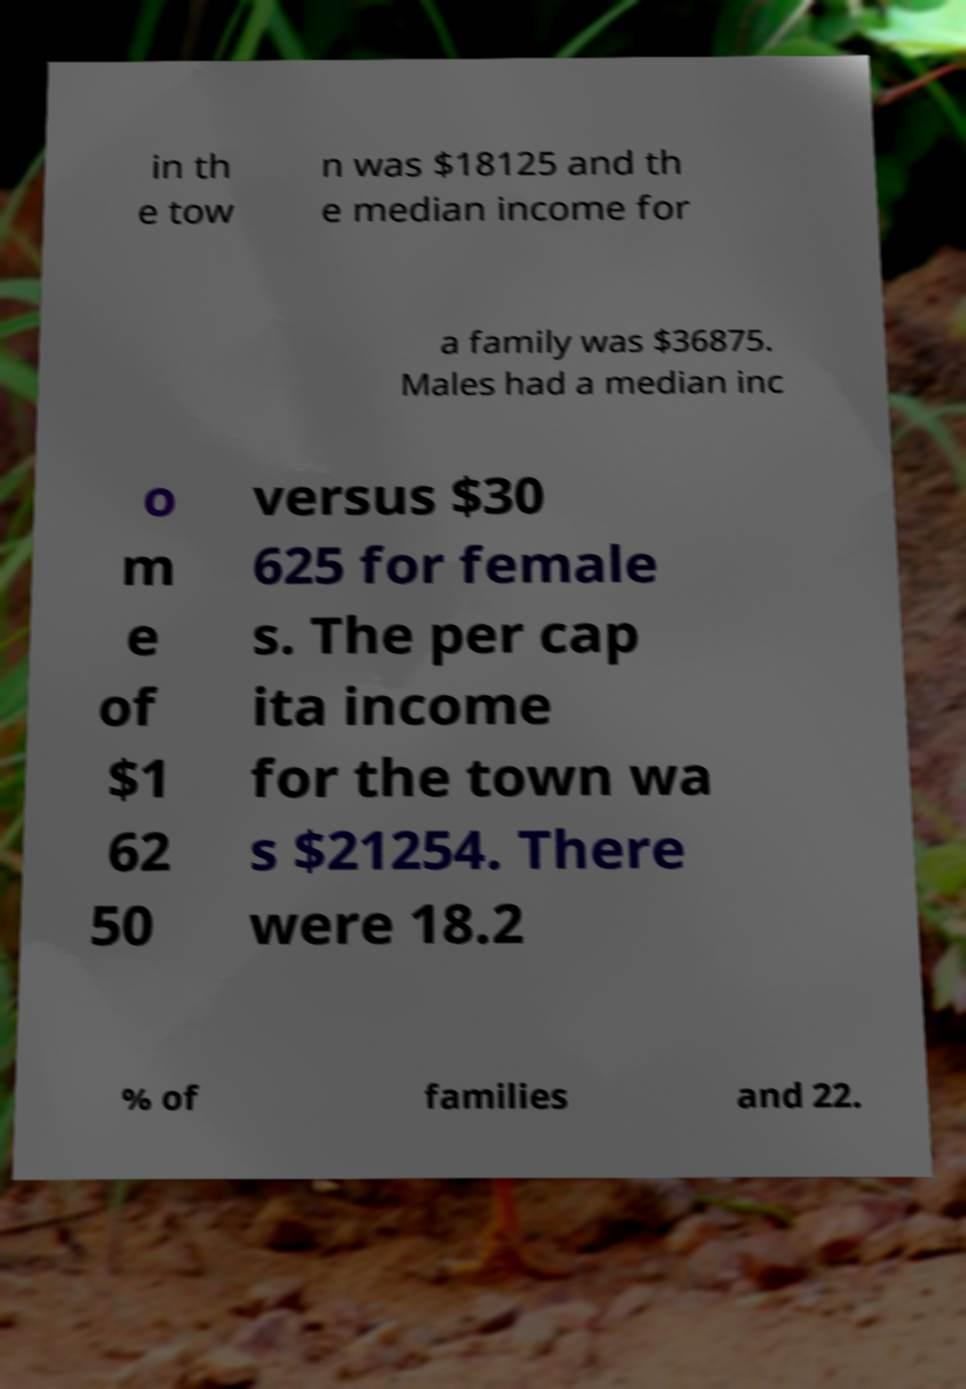For documentation purposes, I need the text within this image transcribed. Could you provide that? in th e tow n was $18125 and th e median income for a family was $36875. Males had a median inc o m e of $1 62 50 versus $30 625 for female s. The per cap ita income for the town wa s $21254. There were 18.2 % of families and 22. 